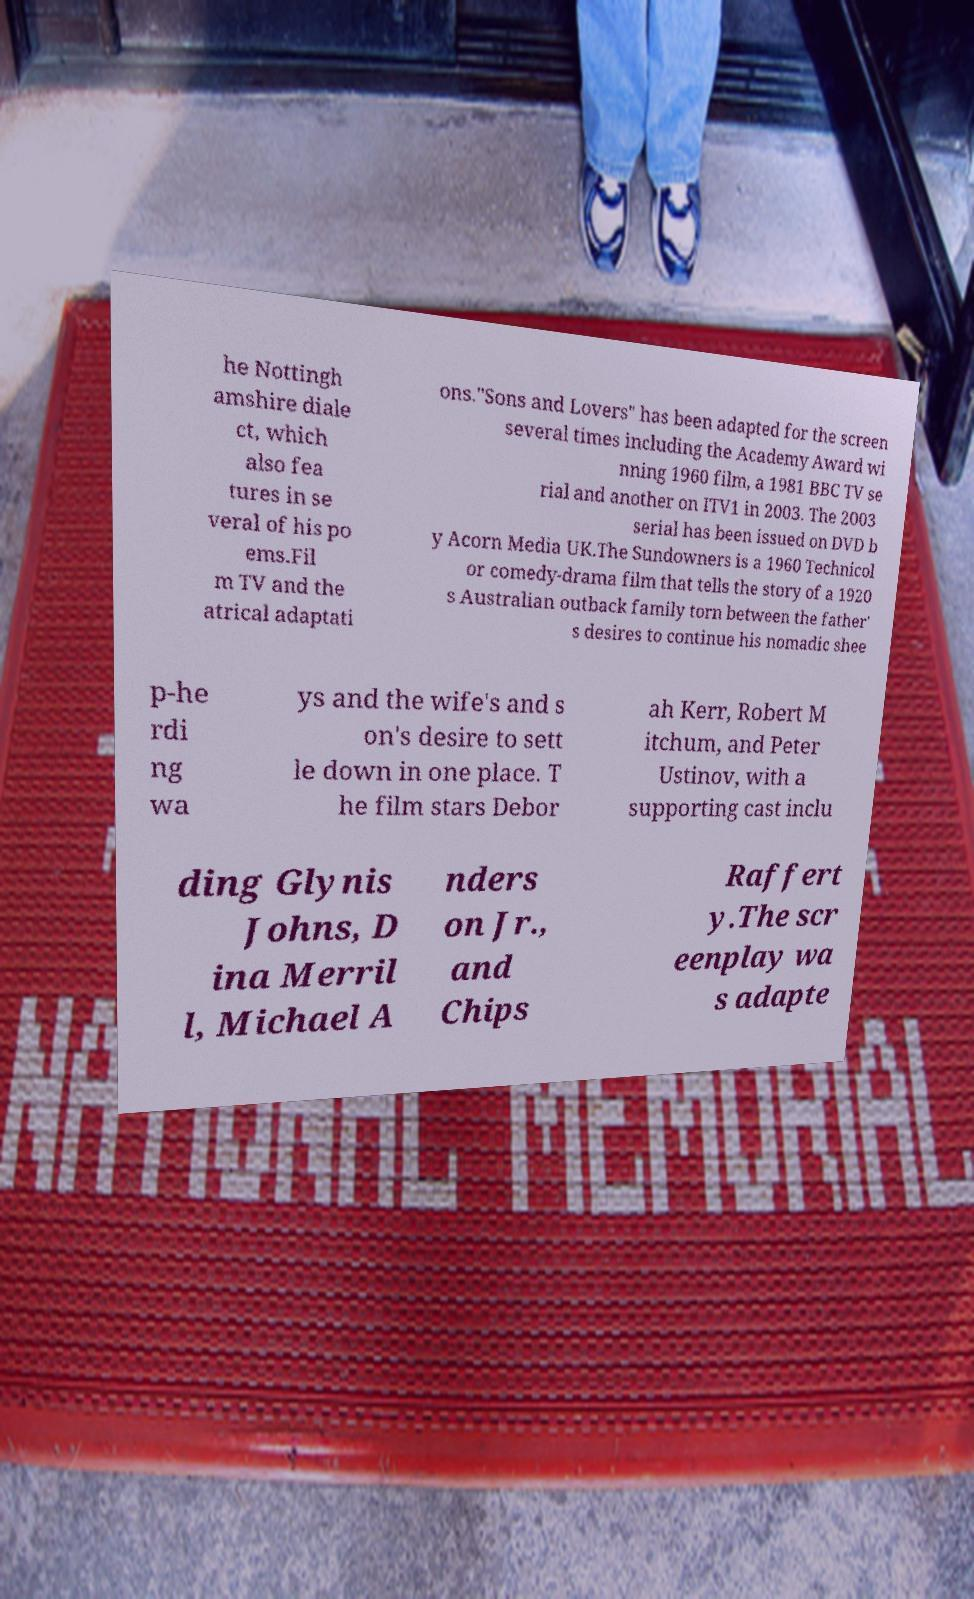Please read and relay the text visible in this image. What does it say? he Nottingh amshire diale ct, which also fea tures in se veral of his po ems.Fil m TV and the atrical adaptati ons."Sons and Lovers" has been adapted for the screen several times including the Academy Award wi nning 1960 film, a 1981 BBC TV se rial and another on ITV1 in 2003. The 2003 serial has been issued on DVD b y Acorn Media UK.The Sundowners is a 1960 Technicol or comedy-drama film that tells the story of a 1920 s Australian outback family torn between the father' s desires to continue his nomadic shee p-he rdi ng wa ys and the wife's and s on's desire to sett le down in one place. T he film stars Debor ah Kerr, Robert M itchum, and Peter Ustinov, with a supporting cast inclu ding Glynis Johns, D ina Merril l, Michael A nders on Jr., and Chips Raffert y.The scr eenplay wa s adapte 